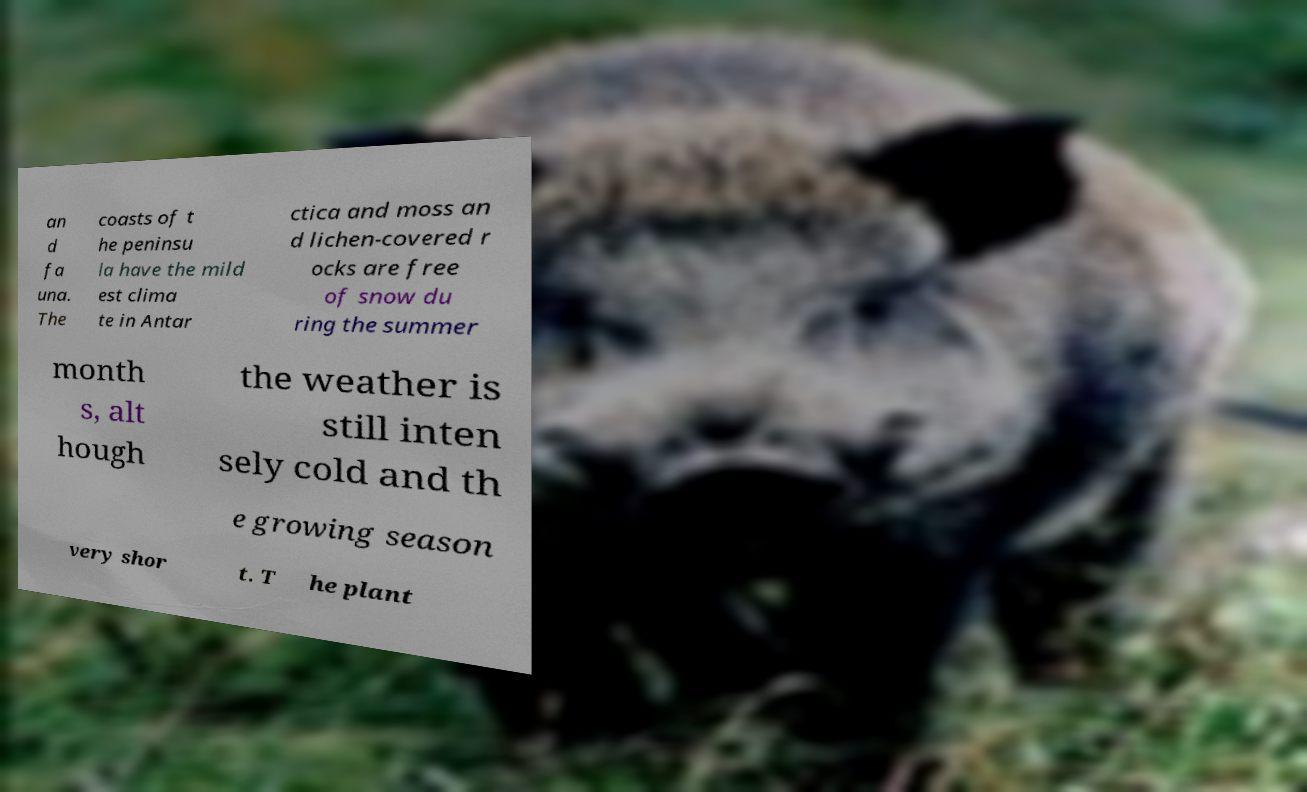Can you accurately transcribe the text from the provided image for me? an d fa una. The coasts of t he peninsu la have the mild est clima te in Antar ctica and moss an d lichen-covered r ocks are free of snow du ring the summer month s, alt hough the weather is still inten sely cold and th e growing season very shor t. T he plant 